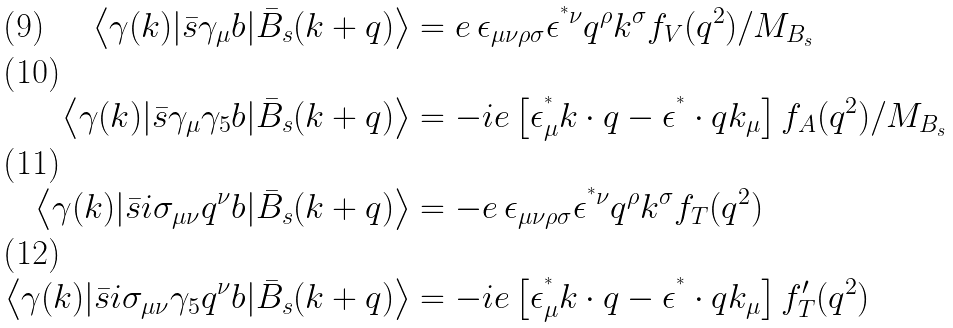Convert formula to latex. <formula><loc_0><loc_0><loc_500><loc_500>\left < \gamma ( k ) | \bar { s } \gamma _ { \mu } b | \bar { B } _ { s } ( k + q ) \right > & = e \, \epsilon _ { \mu \nu \rho \sigma } \epsilon ^ { ^ { * } \nu } q ^ { \rho } k ^ { \sigma } f _ { V } ( q ^ { 2 } ) / M _ { B _ { s } } \\ \left < \gamma ( k ) | \bar { s } \gamma _ { \mu } \gamma _ { 5 } b | \bar { B } _ { s } ( k + q ) \right > & = - i e \left [ \epsilon _ { \mu } ^ { ^ { * } } k \cdot q - \epsilon ^ { ^ { * } } \cdot q k _ { \mu } \right ] f _ { A } ( q ^ { 2 } ) / M _ { B _ { s } } \\ \left < \gamma ( k ) | \bar { s } i \sigma _ { \mu \nu } q ^ { \nu } b | \bar { B } _ { s } ( k + q ) \right > & = - e \, \epsilon _ { \mu \nu \rho \sigma } \epsilon ^ { ^ { * } \nu } q ^ { \rho } k ^ { \sigma } f _ { T } ( q ^ { 2 } ) \\ \left < \gamma ( k ) | \bar { s } i \sigma _ { \mu \nu } \gamma _ { 5 } q ^ { \nu } b | \bar { B } _ { s } ( k + q ) \right > & = - i e \left [ \epsilon ^ { ^ { * } } _ { \mu } k \cdot q - \epsilon ^ { ^ { * } } \cdot q k _ { \mu } \right ] f ^ { \prime } _ { T } ( q ^ { 2 } )</formula> 